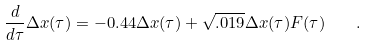Convert formula to latex. <formula><loc_0><loc_0><loc_500><loc_500>\frac { d } { d \tau } \Delta x ( \tau ) = - 0 . 4 4 \Delta x ( \tau ) + \sqrt { . 0 1 9 } \Delta x ( \tau ) F ( \tau ) \quad .</formula> 